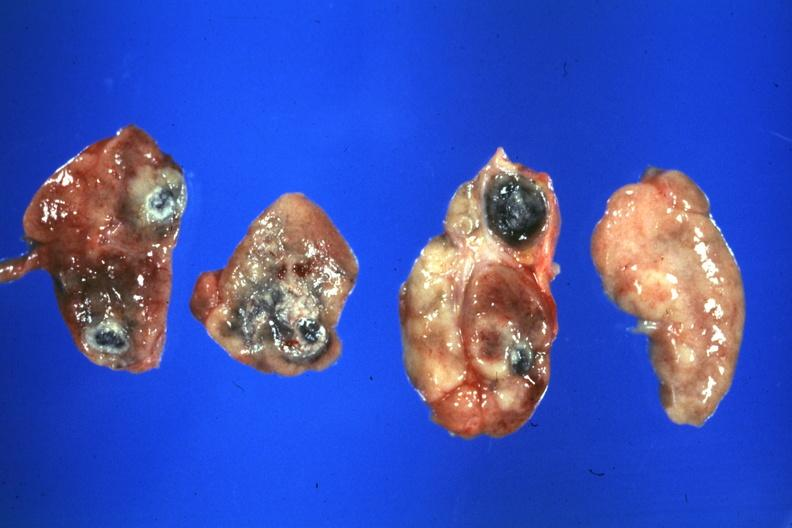s bone, skull present?
Answer the question using a single word or phrase. No 